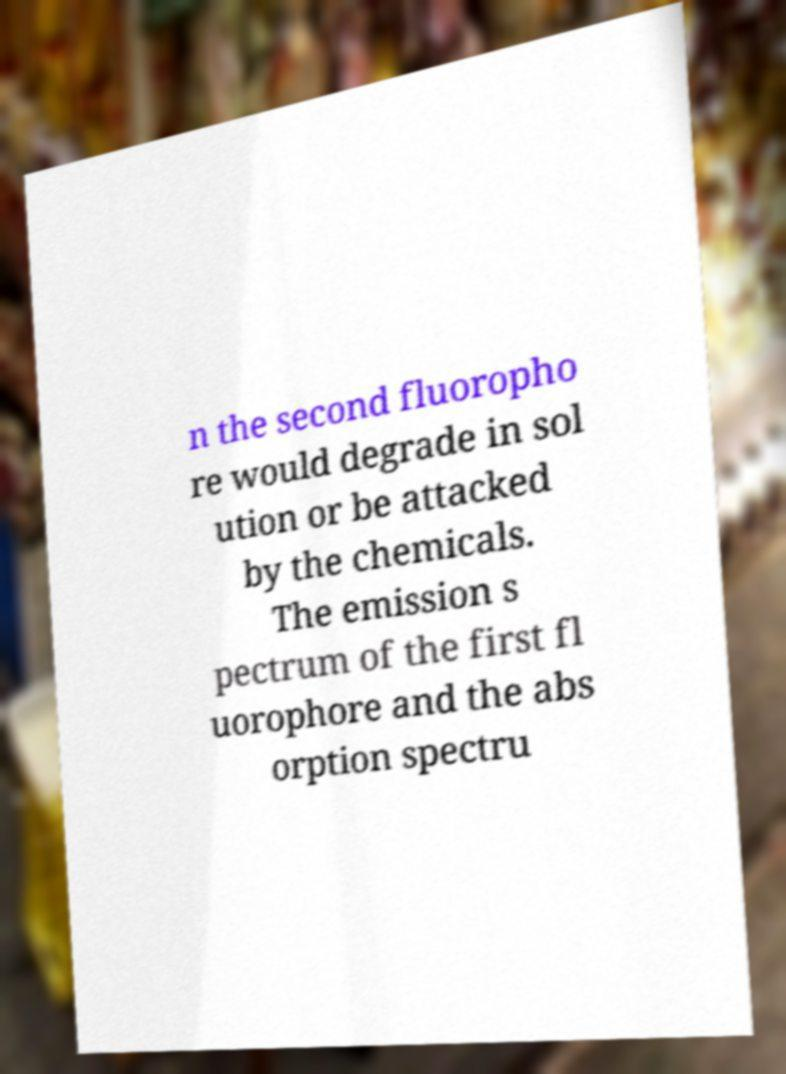Could you extract and type out the text from this image? n the second fluoropho re would degrade in sol ution or be attacked by the chemicals. The emission s pectrum of the first fl uorophore and the abs orption spectru 